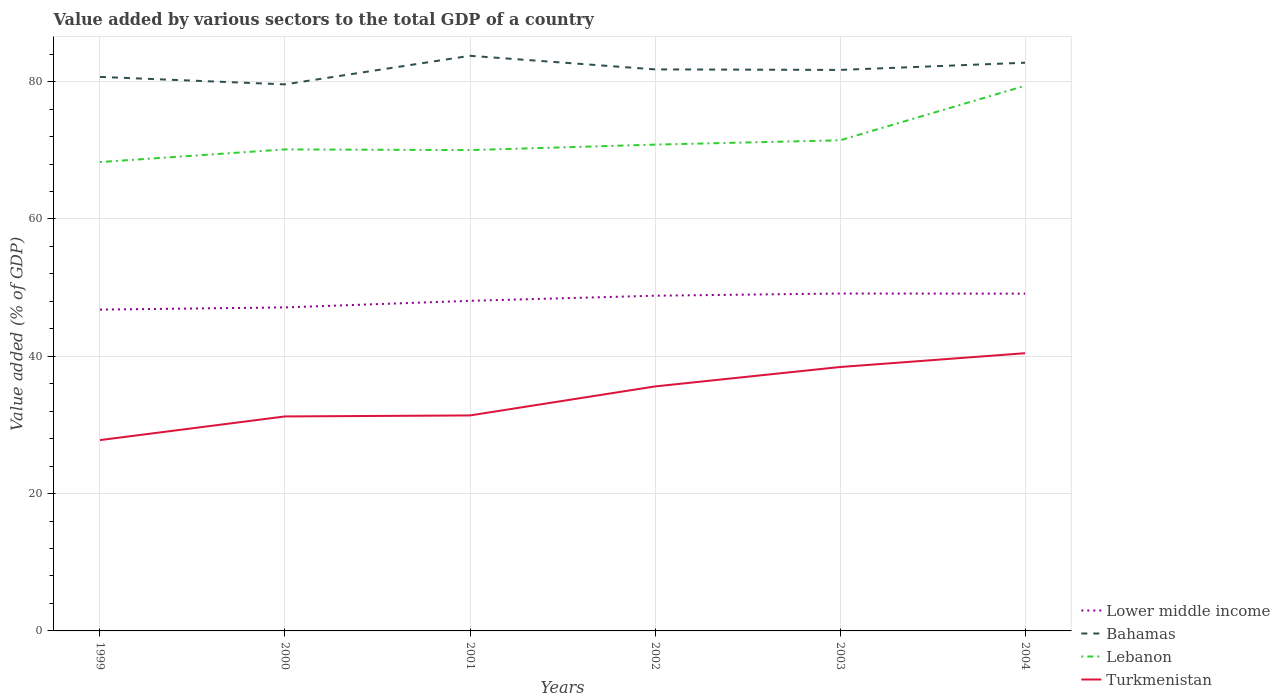How many different coloured lines are there?
Provide a succinct answer. 4. Does the line corresponding to Turkmenistan intersect with the line corresponding to Lower middle income?
Your answer should be very brief. No. Is the number of lines equal to the number of legend labels?
Give a very brief answer. Yes. Across all years, what is the maximum value added by various sectors to the total GDP in Bahamas?
Keep it short and to the point. 79.6. What is the total value added by various sectors to the total GDP in Lower middle income in the graph?
Keep it short and to the point. -2.01. What is the difference between the highest and the second highest value added by various sectors to the total GDP in Bahamas?
Ensure brevity in your answer.  4.16. Is the value added by various sectors to the total GDP in Bahamas strictly greater than the value added by various sectors to the total GDP in Lower middle income over the years?
Provide a succinct answer. No. What is the difference between two consecutive major ticks on the Y-axis?
Make the answer very short. 20. Are the values on the major ticks of Y-axis written in scientific E-notation?
Your response must be concise. No. Does the graph contain grids?
Provide a short and direct response. Yes. Where does the legend appear in the graph?
Your answer should be compact. Bottom right. How many legend labels are there?
Keep it short and to the point. 4. How are the legend labels stacked?
Your response must be concise. Vertical. What is the title of the graph?
Offer a very short reply. Value added by various sectors to the total GDP of a country. What is the label or title of the Y-axis?
Your answer should be compact. Value added (% of GDP). What is the Value added (% of GDP) of Lower middle income in 1999?
Give a very brief answer. 46.8. What is the Value added (% of GDP) in Bahamas in 1999?
Offer a very short reply. 80.69. What is the Value added (% of GDP) of Lebanon in 1999?
Provide a succinct answer. 68.29. What is the Value added (% of GDP) in Turkmenistan in 1999?
Give a very brief answer. 27.79. What is the Value added (% of GDP) in Lower middle income in 2000?
Provide a short and direct response. 47.12. What is the Value added (% of GDP) of Bahamas in 2000?
Your response must be concise. 79.6. What is the Value added (% of GDP) in Lebanon in 2000?
Offer a terse response. 70.13. What is the Value added (% of GDP) in Turkmenistan in 2000?
Provide a short and direct response. 31.24. What is the Value added (% of GDP) of Lower middle income in 2001?
Your response must be concise. 48.08. What is the Value added (% of GDP) of Bahamas in 2001?
Offer a very short reply. 83.77. What is the Value added (% of GDP) in Lebanon in 2001?
Provide a succinct answer. 70.03. What is the Value added (% of GDP) in Turkmenistan in 2001?
Make the answer very short. 31.38. What is the Value added (% of GDP) of Lower middle income in 2002?
Make the answer very short. 48.82. What is the Value added (% of GDP) of Bahamas in 2002?
Your answer should be compact. 81.79. What is the Value added (% of GDP) of Lebanon in 2002?
Offer a very short reply. 70.83. What is the Value added (% of GDP) of Turkmenistan in 2002?
Your response must be concise. 35.61. What is the Value added (% of GDP) of Lower middle income in 2003?
Offer a terse response. 49.14. What is the Value added (% of GDP) in Bahamas in 2003?
Ensure brevity in your answer.  81.71. What is the Value added (% of GDP) of Lebanon in 2003?
Your response must be concise. 71.46. What is the Value added (% of GDP) of Turkmenistan in 2003?
Ensure brevity in your answer.  38.44. What is the Value added (% of GDP) in Lower middle income in 2004?
Your response must be concise. 49.12. What is the Value added (% of GDP) in Bahamas in 2004?
Your answer should be very brief. 82.76. What is the Value added (% of GDP) of Lebanon in 2004?
Ensure brevity in your answer.  79.4. What is the Value added (% of GDP) of Turkmenistan in 2004?
Offer a very short reply. 40.45. Across all years, what is the maximum Value added (% of GDP) of Lower middle income?
Give a very brief answer. 49.14. Across all years, what is the maximum Value added (% of GDP) in Bahamas?
Your answer should be very brief. 83.77. Across all years, what is the maximum Value added (% of GDP) of Lebanon?
Make the answer very short. 79.4. Across all years, what is the maximum Value added (% of GDP) of Turkmenistan?
Your response must be concise. 40.45. Across all years, what is the minimum Value added (% of GDP) in Lower middle income?
Give a very brief answer. 46.8. Across all years, what is the minimum Value added (% of GDP) of Bahamas?
Keep it short and to the point. 79.6. Across all years, what is the minimum Value added (% of GDP) of Lebanon?
Your answer should be compact. 68.29. Across all years, what is the minimum Value added (% of GDP) in Turkmenistan?
Provide a short and direct response. 27.79. What is the total Value added (% of GDP) in Lower middle income in the graph?
Give a very brief answer. 289.08. What is the total Value added (% of GDP) in Bahamas in the graph?
Ensure brevity in your answer.  490.31. What is the total Value added (% of GDP) of Lebanon in the graph?
Keep it short and to the point. 430.13. What is the total Value added (% of GDP) in Turkmenistan in the graph?
Offer a very short reply. 204.91. What is the difference between the Value added (% of GDP) in Lower middle income in 1999 and that in 2000?
Keep it short and to the point. -0.32. What is the difference between the Value added (% of GDP) in Bahamas in 1999 and that in 2000?
Provide a succinct answer. 1.09. What is the difference between the Value added (% of GDP) of Lebanon in 1999 and that in 2000?
Provide a short and direct response. -1.84. What is the difference between the Value added (% of GDP) of Turkmenistan in 1999 and that in 2000?
Provide a short and direct response. -3.45. What is the difference between the Value added (% of GDP) of Lower middle income in 1999 and that in 2001?
Offer a terse response. -1.28. What is the difference between the Value added (% of GDP) in Bahamas in 1999 and that in 2001?
Your response must be concise. -3.07. What is the difference between the Value added (% of GDP) of Lebanon in 1999 and that in 2001?
Give a very brief answer. -1.74. What is the difference between the Value added (% of GDP) of Turkmenistan in 1999 and that in 2001?
Offer a terse response. -3.59. What is the difference between the Value added (% of GDP) of Lower middle income in 1999 and that in 2002?
Your response must be concise. -2.03. What is the difference between the Value added (% of GDP) in Bahamas in 1999 and that in 2002?
Your response must be concise. -1.1. What is the difference between the Value added (% of GDP) in Lebanon in 1999 and that in 2002?
Provide a short and direct response. -2.54. What is the difference between the Value added (% of GDP) of Turkmenistan in 1999 and that in 2002?
Provide a short and direct response. -7.82. What is the difference between the Value added (% of GDP) of Lower middle income in 1999 and that in 2003?
Keep it short and to the point. -2.34. What is the difference between the Value added (% of GDP) in Bahamas in 1999 and that in 2003?
Offer a very short reply. -1.02. What is the difference between the Value added (% of GDP) in Lebanon in 1999 and that in 2003?
Ensure brevity in your answer.  -3.17. What is the difference between the Value added (% of GDP) of Turkmenistan in 1999 and that in 2003?
Make the answer very short. -10.64. What is the difference between the Value added (% of GDP) in Lower middle income in 1999 and that in 2004?
Your response must be concise. -2.33. What is the difference between the Value added (% of GDP) of Bahamas in 1999 and that in 2004?
Make the answer very short. -2.07. What is the difference between the Value added (% of GDP) in Lebanon in 1999 and that in 2004?
Your answer should be very brief. -11.11. What is the difference between the Value added (% of GDP) in Turkmenistan in 1999 and that in 2004?
Ensure brevity in your answer.  -12.66. What is the difference between the Value added (% of GDP) in Lower middle income in 2000 and that in 2001?
Provide a short and direct response. -0.96. What is the difference between the Value added (% of GDP) of Bahamas in 2000 and that in 2001?
Make the answer very short. -4.16. What is the difference between the Value added (% of GDP) in Lebanon in 2000 and that in 2001?
Make the answer very short. 0.1. What is the difference between the Value added (% of GDP) in Turkmenistan in 2000 and that in 2001?
Provide a short and direct response. -0.14. What is the difference between the Value added (% of GDP) in Lower middle income in 2000 and that in 2002?
Provide a succinct answer. -1.71. What is the difference between the Value added (% of GDP) in Bahamas in 2000 and that in 2002?
Give a very brief answer. -2.18. What is the difference between the Value added (% of GDP) in Lebanon in 2000 and that in 2002?
Keep it short and to the point. -0.7. What is the difference between the Value added (% of GDP) of Turkmenistan in 2000 and that in 2002?
Your answer should be compact. -4.37. What is the difference between the Value added (% of GDP) in Lower middle income in 2000 and that in 2003?
Keep it short and to the point. -2.02. What is the difference between the Value added (% of GDP) in Bahamas in 2000 and that in 2003?
Make the answer very short. -2.11. What is the difference between the Value added (% of GDP) of Lebanon in 2000 and that in 2003?
Offer a terse response. -1.33. What is the difference between the Value added (% of GDP) in Turkmenistan in 2000 and that in 2003?
Provide a succinct answer. -7.2. What is the difference between the Value added (% of GDP) in Lower middle income in 2000 and that in 2004?
Offer a terse response. -2.01. What is the difference between the Value added (% of GDP) of Bahamas in 2000 and that in 2004?
Your answer should be compact. -3.15. What is the difference between the Value added (% of GDP) of Lebanon in 2000 and that in 2004?
Ensure brevity in your answer.  -9.27. What is the difference between the Value added (% of GDP) of Turkmenistan in 2000 and that in 2004?
Your answer should be compact. -9.21. What is the difference between the Value added (% of GDP) in Lower middle income in 2001 and that in 2002?
Give a very brief answer. -0.75. What is the difference between the Value added (% of GDP) of Bahamas in 2001 and that in 2002?
Keep it short and to the point. 1.98. What is the difference between the Value added (% of GDP) of Lebanon in 2001 and that in 2002?
Offer a terse response. -0.8. What is the difference between the Value added (% of GDP) of Turkmenistan in 2001 and that in 2002?
Provide a succinct answer. -4.22. What is the difference between the Value added (% of GDP) of Lower middle income in 2001 and that in 2003?
Your answer should be very brief. -1.06. What is the difference between the Value added (% of GDP) in Bahamas in 2001 and that in 2003?
Offer a terse response. 2.06. What is the difference between the Value added (% of GDP) of Lebanon in 2001 and that in 2003?
Your answer should be compact. -1.43. What is the difference between the Value added (% of GDP) of Turkmenistan in 2001 and that in 2003?
Give a very brief answer. -7.05. What is the difference between the Value added (% of GDP) of Lower middle income in 2001 and that in 2004?
Your answer should be compact. -1.05. What is the difference between the Value added (% of GDP) in Bahamas in 2001 and that in 2004?
Offer a very short reply. 1.01. What is the difference between the Value added (% of GDP) in Lebanon in 2001 and that in 2004?
Provide a short and direct response. -9.37. What is the difference between the Value added (% of GDP) in Turkmenistan in 2001 and that in 2004?
Give a very brief answer. -9.06. What is the difference between the Value added (% of GDP) in Lower middle income in 2002 and that in 2003?
Ensure brevity in your answer.  -0.32. What is the difference between the Value added (% of GDP) in Bahamas in 2002 and that in 2003?
Keep it short and to the point. 0.08. What is the difference between the Value added (% of GDP) in Lebanon in 2002 and that in 2003?
Ensure brevity in your answer.  -0.63. What is the difference between the Value added (% of GDP) of Turkmenistan in 2002 and that in 2003?
Offer a very short reply. -2.83. What is the difference between the Value added (% of GDP) of Lower middle income in 2002 and that in 2004?
Provide a short and direct response. -0.3. What is the difference between the Value added (% of GDP) of Bahamas in 2002 and that in 2004?
Make the answer very short. -0.97. What is the difference between the Value added (% of GDP) in Lebanon in 2002 and that in 2004?
Make the answer very short. -8.57. What is the difference between the Value added (% of GDP) of Turkmenistan in 2002 and that in 2004?
Keep it short and to the point. -4.84. What is the difference between the Value added (% of GDP) in Lower middle income in 2003 and that in 2004?
Provide a succinct answer. 0.02. What is the difference between the Value added (% of GDP) in Bahamas in 2003 and that in 2004?
Your response must be concise. -1.05. What is the difference between the Value added (% of GDP) of Lebanon in 2003 and that in 2004?
Offer a very short reply. -7.94. What is the difference between the Value added (% of GDP) of Turkmenistan in 2003 and that in 2004?
Offer a very short reply. -2.01. What is the difference between the Value added (% of GDP) in Lower middle income in 1999 and the Value added (% of GDP) in Bahamas in 2000?
Offer a very short reply. -32.8. What is the difference between the Value added (% of GDP) of Lower middle income in 1999 and the Value added (% of GDP) of Lebanon in 2000?
Keep it short and to the point. -23.33. What is the difference between the Value added (% of GDP) of Lower middle income in 1999 and the Value added (% of GDP) of Turkmenistan in 2000?
Your answer should be very brief. 15.56. What is the difference between the Value added (% of GDP) in Bahamas in 1999 and the Value added (% of GDP) in Lebanon in 2000?
Your response must be concise. 10.56. What is the difference between the Value added (% of GDP) in Bahamas in 1999 and the Value added (% of GDP) in Turkmenistan in 2000?
Give a very brief answer. 49.45. What is the difference between the Value added (% of GDP) in Lebanon in 1999 and the Value added (% of GDP) in Turkmenistan in 2000?
Offer a terse response. 37.05. What is the difference between the Value added (% of GDP) in Lower middle income in 1999 and the Value added (% of GDP) in Bahamas in 2001?
Your answer should be compact. -36.97. What is the difference between the Value added (% of GDP) in Lower middle income in 1999 and the Value added (% of GDP) in Lebanon in 2001?
Offer a terse response. -23.23. What is the difference between the Value added (% of GDP) in Lower middle income in 1999 and the Value added (% of GDP) in Turkmenistan in 2001?
Your answer should be compact. 15.41. What is the difference between the Value added (% of GDP) in Bahamas in 1999 and the Value added (% of GDP) in Lebanon in 2001?
Provide a short and direct response. 10.66. What is the difference between the Value added (% of GDP) in Bahamas in 1999 and the Value added (% of GDP) in Turkmenistan in 2001?
Provide a short and direct response. 49.31. What is the difference between the Value added (% of GDP) in Lebanon in 1999 and the Value added (% of GDP) in Turkmenistan in 2001?
Your answer should be compact. 36.9. What is the difference between the Value added (% of GDP) of Lower middle income in 1999 and the Value added (% of GDP) of Bahamas in 2002?
Your response must be concise. -34.99. What is the difference between the Value added (% of GDP) of Lower middle income in 1999 and the Value added (% of GDP) of Lebanon in 2002?
Provide a short and direct response. -24.03. What is the difference between the Value added (% of GDP) of Lower middle income in 1999 and the Value added (% of GDP) of Turkmenistan in 2002?
Provide a short and direct response. 11.19. What is the difference between the Value added (% of GDP) of Bahamas in 1999 and the Value added (% of GDP) of Lebanon in 2002?
Offer a very short reply. 9.86. What is the difference between the Value added (% of GDP) of Bahamas in 1999 and the Value added (% of GDP) of Turkmenistan in 2002?
Ensure brevity in your answer.  45.08. What is the difference between the Value added (% of GDP) of Lebanon in 1999 and the Value added (% of GDP) of Turkmenistan in 2002?
Your answer should be compact. 32.68. What is the difference between the Value added (% of GDP) of Lower middle income in 1999 and the Value added (% of GDP) of Bahamas in 2003?
Offer a very short reply. -34.91. What is the difference between the Value added (% of GDP) of Lower middle income in 1999 and the Value added (% of GDP) of Lebanon in 2003?
Ensure brevity in your answer.  -24.66. What is the difference between the Value added (% of GDP) of Lower middle income in 1999 and the Value added (% of GDP) of Turkmenistan in 2003?
Make the answer very short. 8.36. What is the difference between the Value added (% of GDP) of Bahamas in 1999 and the Value added (% of GDP) of Lebanon in 2003?
Provide a succinct answer. 9.23. What is the difference between the Value added (% of GDP) in Bahamas in 1999 and the Value added (% of GDP) in Turkmenistan in 2003?
Offer a very short reply. 42.25. What is the difference between the Value added (% of GDP) in Lebanon in 1999 and the Value added (% of GDP) in Turkmenistan in 2003?
Your answer should be compact. 29.85. What is the difference between the Value added (% of GDP) of Lower middle income in 1999 and the Value added (% of GDP) of Bahamas in 2004?
Your response must be concise. -35.96. What is the difference between the Value added (% of GDP) in Lower middle income in 1999 and the Value added (% of GDP) in Lebanon in 2004?
Your response must be concise. -32.6. What is the difference between the Value added (% of GDP) of Lower middle income in 1999 and the Value added (% of GDP) of Turkmenistan in 2004?
Your response must be concise. 6.35. What is the difference between the Value added (% of GDP) of Bahamas in 1999 and the Value added (% of GDP) of Lebanon in 2004?
Offer a very short reply. 1.29. What is the difference between the Value added (% of GDP) of Bahamas in 1999 and the Value added (% of GDP) of Turkmenistan in 2004?
Your response must be concise. 40.24. What is the difference between the Value added (% of GDP) of Lebanon in 1999 and the Value added (% of GDP) of Turkmenistan in 2004?
Ensure brevity in your answer.  27.84. What is the difference between the Value added (% of GDP) in Lower middle income in 2000 and the Value added (% of GDP) in Bahamas in 2001?
Keep it short and to the point. -36.65. What is the difference between the Value added (% of GDP) in Lower middle income in 2000 and the Value added (% of GDP) in Lebanon in 2001?
Your answer should be very brief. -22.91. What is the difference between the Value added (% of GDP) in Lower middle income in 2000 and the Value added (% of GDP) in Turkmenistan in 2001?
Offer a terse response. 15.73. What is the difference between the Value added (% of GDP) of Bahamas in 2000 and the Value added (% of GDP) of Lebanon in 2001?
Ensure brevity in your answer.  9.57. What is the difference between the Value added (% of GDP) of Bahamas in 2000 and the Value added (% of GDP) of Turkmenistan in 2001?
Provide a short and direct response. 48.22. What is the difference between the Value added (% of GDP) in Lebanon in 2000 and the Value added (% of GDP) in Turkmenistan in 2001?
Make the answer very short. 38.75. What is the difference between the Value added (% of GDP) of Lower middle income in 2000 and the Value added (% of GDP) of Bahamas in 2002?
Give a very brief answer. -34.67. What is the difference between the Value added (% of GDP) of Lower middle income in 2000 and the Value added (% of GDP) of Lebanon in 2002?
Provide a succinct answer. -23.71. What is the difference between the Value added (% of GDP) in Lower middle income in 2000 and the Value added (% of GDP) in Turkmenistan in 2002?
Ensure brevity in your answer.  11.51. What is the difference between the Value added (% of GDP) of Bahamas in 2000 and the Value added (% of GDP) of Lebanon in 2002?
Make the answer very short. 8.77. What is the difference between the Value added (% of GDP) of Bahamas in 2000 and the Value added (% of GDP) of Turkmenistan in 2002?
Give a very brief answer. 43.99. What is the difference between the Value added (% of GDP) in Lebanon in 2000 and the Value added (% of GDP) in Turkmenistan in 2002?
Offer a very short reply. 34.52. What is the difference between the Value added (% of GDP) in Lower middle income in 2000 and the Value added (% of GDP) in Bahamas in 2003?
Provide a succinct answer. -34.59. What is the difference between the Value added (% of GDP) of Lower middle income in 2000 and the Value added (% of GDP) of Lebanon in 2003?
Provide a succinct answer. -24.34. What is the difference between the Value added (% of GDP) of Lower middle income in 2000 and the Value added (% of GDP) of Turkmenistan in 2003?
Offer a terse response. 8.68. What is the difference between the Value added (% of GDP) of Bahamas in 2000 and the Value added (% of GDP) of Lebanon in 2003?
Your answer should be compact. 8.14. What is the difference between the Value added (% of GDP) in Bahamas in 2000 and the Value added (% of GDP) in Turkmenistan in 2003?
Provide a short and direct response. 41.17. What is the difference between the Value added (% of GDP) in Lebanon in 2000 and the Value added (% of GDP) in Turkmenistan in 2003?
Your answer should be very brief. 31.69. What is the difference between the Value added (% of GDP) of Lower middle income in 2000 and the Value added (% of GDP) of Bahamas in 2004?
Your answer should be very brief. -35.64. What is the difference between the Value added (% of GDP) of Lower middle income in 2000 and the Value added (% of GDP) of Lebanon in 2004?
Ensure brevity in your answer.  -32.28. What is the difference between the Value added (% of GDP) in Lower middle income in 2000 and the Value added (% of GDP) in Turkmenistan in 2004?
Offer a terse response. 6.67. What is the difference between the Value added (% of GDP) in Bahamas in 2000 and the Value added (% of GDP) in Lebanon in 2004?
Offer a very short reply. 0.21. What is the difference between the Value added (% of GDP) of Bahamas in 2000 and the Value added (% of GDP) of Turkmenistan in 2004?
Ensure brevity in your answer.  39.15. What is the difference between the Value added (% of GDP) of Lebanon in 2000 and the Value added (% of GDP) of Turkmenistan in 2004?
Keep it short and to the point. 29.68. What is the difference between the Value added (% of GDP) of Lower middle income in 2001 and the Value added (% of GDP) of Bahamas in 2002?
Your answer should be very brief. -33.71. What is the difference between the Value added (% of GDP) in Lower middle income in 2001 and the Value added (% of GDP) in Lebanon in 2002?
Provide a short and direct response. -22.75. What is the difference between the Value added (% of GDP) of Lower middle income in 2001 and the Value added (% of GDP) of Turkmenistan in 2002?
Your answer should be compact. 12.47. What is the difference between the Value added (% of GDP) in Bahamas in 2001 and the Value added (% of GDP) in Lebanon in 2002?
Keep it short and to the point. 12.94. What is the difference between the Value added (% of GDP) of Bahamas in 2001 and the Value added (% of GDP) of Turkmenistan in 2002?
Offer a terse response. 48.16. What is the difference between the Value added (% of GDP) in Lebanon in 2001 and the Value added (% of GDP) in Turkmenistan in 2002?
Make the answer very short. 34.42. What is the difference between the Value added (% of GDP) of Lower middle income in 2001 and the Value added (% of GDP) of Bahamas in 2003?
Your answer should be compact. -33.63. What is the difference between the Value added (% of GDP) in Lower middle income in 2001 and the Value added (% of GDP) in Lebanon in 2003?
Provide a succinct answer. -23.38. What is the difference between the Value added (% of GDP) of Lower middle income in 2001 and the Value added (% of GDP) of Turkmenistan in 2003?
Keep it short and to the point. 9.64. What is the difference between the Value added (% of GDP) in Bahamas in 2001 and the Value added (% of GDP) in Lebanon in 2003?
Ensure brevity in your answer.  12.31. What is the difference between the Value added (% of GDP) of Bahamas in 2001 and the Value added (% of GDP) of Turkmenistan in 2003?
Give a very brief answer. 45.33. What is the difference between the Value added (% of GDP) in Lebanon in 2001 and the Value added (% of GDP) in Turkmenistan in 2003?
Provide a short and direct response. 31.59. What is the difference between the Value added (% of GDP) of Lower middle income in 2001 and the Value added (% of GDP) of Bahamas in 2004?
Provide a succinct answer. -34.68. What is the difference between the Value added (% of GDP) of Lower middle income in 2001 and the Value added (% of GDP) of Lebanon in 2004?
Offer a very short reply. -31.32. What is the difference between the Value added (% of GDP) in Lower middle income in 2001 and the Value added (% of GDP) in Turkmenistan in 2004?
Your answer should be very brief. 7.63. What is the difference between the Value added (% of GDP) of Bahamas in 2001 and the Value added (% of GDP) of Lebanon in 2004?
Offer a very short reply. 4.37. What is the difference between the Value added (% of GDP) in Bahamas in 2001 and the Value added (% of GDP) in Turkmenistan in 2004?
Offer a very short reply. 43.32. What is the difference between the Value added (% of GDP) of Lebanon in 2001 and the Value added (% of GDP) of Turkmenistan in 2004?
Give a very brief answer. 29.58. What is the difference between the Value added (% of GDP) in Lower middle income in 2002 and the Value added (% of GDP) in Bahamas in 2003?
Provide a short and direct response. -32.88. What is the difference between the Value added (% of GDP) of Lower middle income in 2002 and the Value added (% of GDP) of Lebanon in 2003?
Offer a terse response. -22.63. What is the difference between the Value added (% of GDP) in Lower middle income in 2002 and the Value added (% of GDP) in Turkmenistan in 2003?
Your answer should be very brief. 10.39. What is the difference between the Value added (% of GDP) in Bahamas in 2002 and the Value added (% of GDP) in Lebanon in 2003?
Give a very brief answer. 10.33. What is the difference between the Value added (% of GDP) of Bahamas in 2002 and the Value added (% of GDP) of Turkmenistan in 2003?
Offer a very short reply. 43.35. What is the difference between the Value added (% of GDP) in Lebanon in 2002 and the Value added (% of GDP) in Turkmenistan in 2003?
Offer a terse response. 32.39. What is the difference between the Value added (% of GDP) of Lower middle income in 2002 and the Value added (% of GDP) of Bahamas in 2004?
Your response must be concise. -33.93. What is the difference between the Value added (% of GDP) of Lower middle income in 2002 and the Value added (% of GDP) of Lebanon in 2004?
Your response must be concise. -30.57. What is the difference between the Value added (% of GDP) of Lower middle income in 2002 and the Value added (% of GDP) of Turkmenistan in 2004?
Give a very brief answer. 8.38. What is the difference between the Value added (% of GDP) of Bahamas in 2002 and the Value added (% of GDP) of Lebanon in 2004?
Offer a terse response. 2.39. What is the difference between the Value added (% of GDP) in Bahamas in 2002 and the Value added (% of GDP) in Turkmenistan in 2004?
Keep it short and to the point. 41.34. What is the difference between the Value added (% of GDP) in Lebanon in 2002 and the Value added (% of GDP) in Turkmenistan in 2004?
Your response must be concise. 30.38. What is the difference between the Value added (% of GDP) of Lower middle income in 2003 and the Value added (% of GDP) of Bahamas in 2004?
Make the answer very short. -33.62. What is the difference between the Value added (% of GDP) of Lower middle income in 2003 and the Value added (% of GDP) of Lebanon in 2004?
Provide a short and direct response. -30.26. What is the difference between the Value added (% of GDP) of Lower middle income in 2003 and the Value added (% of GDP) of Turkmenistan in 2004?
Your response must be concise. 8.69. What is the difference between the Value added (% of GDP) in Bahamas in 2003 and the Value added (% of GDP) in Lebanon in 2004?
Provide a succinct answer. 2.31. What is the difference between the Value added (% of GDP) of Bahamas in 2003 and the Value added (% of GDP) of Turkmenistan in 2004?
Offer a terse response. 41.26. What is the difference between the Value added (% of GDP) in Lebanon in 2003 and the Value added (% of GDP) in Turkmenistan in 2004?
Your answer should be very brief. 31.01. What is the average Value added (% of GDP) in Lower middle income per year?
Keep it short and to the point. 48.18. What is the average Value added (% of GDP) of Bahamas per year?
Make the answer very short. 81.72. What is the average Value added (% of GDP) in Lebanon per year?
Keep it short and to the point. 71.69. What is the average Value added (% of GDP) in Turkmenistan per year?
Offer a terse response. 34.15. In the year 1999, what is the difference between the Value added (% of GDP) of Lower middle income and Value added (% of GDP) of Bahamas?
Give a very brief answer. -33.89. In the year 1999, what is the difference between the Value added (% of GDP) in Lower middle income and Value added (% of GDP) in Lebanon?
Give a very brief answer. -21.49. In the year 1999, what is the difference between the Value added (% of GDP) in Lower middle income and Value added (% of GDP) in Turkmenistan?
Offer a terse response. 19. In the year 1999, what is the difference between the Value added (% of GDP) in Bahamas and Value added (% of GDP) in Lebanon?
Offer a terse response. 12.4. In the year 1999, what is the difference between the Value added (% of GDP) of Bahamas and Value added (% of GDP) of Turkmenistan?
Provide a short and direct response. 52.9. In the year 1999, what is the difference between the Value added (% of GDP) in Lebanon and Value added (% of GDP) in Turkmenistan?
Your response must be concise. 40.5. In the year 2000, what is the difference between the Value added (% of GDP) of Lower middle income and Value added (% of GDP) of Bahamas?
Provide a succinct answer. -32.48. In the year 2000, what is the difference between the Value added (% of GDP) in Lower middle income and Value added (% of GDP) in Lebanon?
Your answer should be compact. -23.01. In the year 2000, what is the difference between the Value added (% of GDP) in Lower middle income and Value added (% of GDP) in Turkmenistan?
Provide a short and direct response. 15.88. In the year 2000, what is the difference between the Value added (% of GDP) of Bahamas and Value added (% of GDP) of Lebanon?
Ensure brevity in your answer.  9.47. In the year 2000, what is the difference between the Value added (% of GDP) of Bahamas and Value added (% of GDP) of Turkmenistan?
Give a very brief answer. 48.36. In the year 2000, what is the difference between the Value added (% of GDP) of Lebanon and Value added (% of GDP) of Turkmenistan?
Provide a succinct answer. 38.89. In the year 2001, what is the difference between the Value added (% of GDP) in Lower middle income and Value added (% of GDP) in Bahamas?
Offer a very short reply. -35.69. In the year 2001, what is the difference between the Value added (% of GDP) in Lower middle income and Value added (% of GDP) in Lebanon?
Provide a short and direct response. -21.95. In the year 2001, what is the difference between the Value added (% of GDP) in Lower middle income and Value added (% of GDP) in Turkmenistan?
Make the answer very short. 16.69. In the year 2001, what is the difference between the Value added (% of GDP) in Bahamas and Value added (% of GDP) in Lebanon?
Offer a very short reply. 13.73. In the year 2001, what is the difference between the Value added (% of GDP) in Bahamas and Value added (% of GDP) in Turkmenistan?
Make the answer very short. 52.38. In the year 2001, what is the difference between the Value added (% of GDP) in Lebanon and Value added (% of GDP) in Turkmenistan?
Your answer should be compact. 38.65. In the year 2002, what is the difference between the Value added (% of GDP) of Lower middle income and Value added (% of GDP) of Bahamas?
Ensure brevity in your answer.  -32.96. In the year 2002, what is the difference between the Value added (% of GDP) in Lower middle income and Value added (% of GDP) in Lebanon?
Give a very brief answer. -22. In the year 2002, what is the difference between the Value added (% of GDP) of Lower middle income and Value added (% of GDP) of Turkmenistan?
Give a very brief answer. 13.21. In the year 2002, what is the difference between the Value added (% of GDP) of Bahamas and Value added (% of GDP) of Lebanon?
Provide a short and direct response. 10.96. In the year 2002, what is the difference between the Value added (% of GDP) in Bahamas and Value added (% of GDP) in Turkmenistan?
Give a very brief answer. 46.18. In the year 2002, what is the difference between the Value added (% of GDP) in Lebanon and Value added (% of GDP) in Turkmenistan?
Your answer should be compact. 35.22. In the year 2003, what is the difference between the Value added (% of GDP) of Lower middle income and Value added (% of GDP) of Bahamas?
Provide a short and direct response. -32.57. In the year 2003, what is the difference between the Value added (% of GDP) of Lower middle income and Value added (% of GDP) of Lebanon?
Make the answer very short. -22.32. In the year 2003, what is the difference between the Value added (% of GDP) of Lower middle income and Value added (% of GDP) of Turkmenistan?
Keep it short and to the point. 10.7. In the year 2003, what is the difference between the Value added (% of GDP) in Bahamas and Value added (% of GDP) in Lebanon?
Your answer should be very brief. 10.25. In the year 2003, what is the difference between the Value added (% of GDP) of Bahamas and Value added (% of GDP) of Turkmenistan?
Provide a short and direct response. 43.27. In the year 2003, what is the difference between the Value added (% of GDP) of Lebanon and Value added (% of GDP) of Turkmenistan?
Make the answer very short. 33.02. In the year 2004, what is the difference between the Value added (% of GDP) of Lower middle income and Value added (% of GDP) of Bahamas?
Give a very brief answer. -33.63. In the year 2004, what is the difference between the Value added (% of GDP) of Lower middle income and Value added (% of GDP) of Lebanon?
Your answer should be compact. -30.27. In the year 2004, what is the difference between the Value added (% of GDP) in Lower middle income and Value added (% of GDP) in Turkmenistan?
Provide a short and direct response. 8.68. In the year 2004, what is the difference between the Value added (% of GDP) of Bahamas and Value added (% of GDP) of Lebanon?
Provide a short and direct response. 3.36. In the year 2004, what is the difference between the Value added (% of GDP) of Bahamas and Value added (% of GDP) of Turkmenistan?
Your answer should be very brief. 42.31. In the year 2004, what is the difference between the Value added (% of GDP) in Lebanon and Value added (% of GDP) in Turkmenistan?
Give a very brief answer. 38.95. What is the ratio of the Value added (% of GDP) of Lower middle income in 1999 to that in 2000?
Provide a short and direct response. 0.99. What is the ratio of the Value added (% of GDP) in Bahamas in 1999 to that in 2000?
Keep it short and to the point. 1.01. What is the ratio of the Value added (% of GDP) in Lebanon in 1999 to that in 2000?
Give a very brief answer. 0.97. What is the ratio of the Value added (% of GDP) in Turkmenistan in 1999 to that in 2000?
Your answer should be very brief. 0.89. What is the ratio of the Value added (% of GDP) in Lower middle income in 1999 to that in 2001?
Your response must be concise. 0.97. What is the ratio of the Value added (% of GDP) in Bahamas in 1999 to that in 2001?
Give a very brief answer. 0.96. What is the ratio of the Value added (% of GDP) in Lebanon in 1999 to that in 2001?
Give a very brief answer. 0.98. What is the ratio of the Value added (% of GDP) in Turkmenistan in 1999 to that in 2001?
Your answer should be compact. 0.89. What is the ratio of the Value added (% of GDP) of Lower middle income in 1999 to that in 2002?
Give a very brief answer. 0.96. What is the ratio of the Value added (% of GDP) in Bahamas in 1999 to that in 2002?
Ensure brevity in your answer.  0.99. What is the ratio of the Value added (% of GDP) of Lebanon in 1999 to that in 2002?
Your answer should be compact. 0.96. What is the ratio of the Value added (% of GDP) in Turkmenistan in 1999 to that in 2002?
Keep it short and to the point. 0.78. What is the ratio of the Value added (% of GDP) of Lower middle income in 1999 to that in 2003?
Your answer should be compact. 0.95. What is the ratio of the Value added (% of GDP) of Bahamas in 1999 to that in 2003?
Make the answer very short. 0.99. What is the ratio of the Value added (% of GDP) in Lebanon in 1999 to that in 2003?
Provide a succinct answer. 0.96. What is the ratio of the Value added (% of GDP) in Turkmenistan in 1999 to that in 2003?
Your answer should be compact. 0.72. What is the ratio of the Value added (% of GDP) in Lower middle income in 1999 to that in 2004?
Provide a succinct answer. 0.95. What is the ratio of the Value added (% of GDP) of Lebanon in 1999 to that in 2004?
Your answer should be compact. 0.86. What is the ratio of the Value added (% of GDP) of Turkmenistan in 1999 to that in 2004?
Keep it short and to the point. 0.69. What is the ratio of the Value added (% of GDP) of Lower middle income in 2000 to that in 2001?
Offer a very short reply. 0.98. What is the ratio of the Value added (% of GDP) in Bahamas in 2000 to that in 2001?
Offer a terse response. 0.95. What is the ratio of the Value added (% of GDP) of Lower middle income in 2000 to that in 2002?
Give a very brief answer. 0.97. What is the ratio of the Value added (% of GDP) in Bahamas in 2000 to that in 2002?
Your answer should be compact. 0.97. What is the ratio of the Value added (% of GDP) of Turkmenistan in 2000 to that in 2002?
Provide a succinct answer. 0.88. What is the ratio of the Value added (% of GDP) in Lower middle income in 2000 to that in 2003?
Your response must be concise. 0.96. What is the ratio of the Value added (% of GDP) of Bahamas in 2000 to that in 2003?
Ensure brevity in your answer.  0.97. What is the ratio of the Value added (% of GDP) in Lebanon in 2000 to that in 2003?
Ensure brevity in your answer.  0.98. What is the ratio of the Value added (% of GDP) in Turkmenistan in 2000 to that in 2003?
Your response must be concise. 0.81. What is the ratio of the Value added (% of GDP) of Lower middle income in 2000 to that in 2004?
Ensure brevity in your answer.  0.96. What is the ratio of the Value added (% of GDP) in Bahamas in 2000 to that in 2004?
Make the answer very short. 0.96. What is the ratio of the Value added (% of GDP) in Lebanon in 2000 to that in 2004?
Give a very brief answer. 0.88. What is the ratio of the Value added (% of GDP) in Turkmenistan in 2000 to that in 2004?
Provide a short and direct response. 0.77. What is the ratio of the Value added (% of GDP) in Lower middle income in 2001 to that in 2002?
Make the answer very short. 0.98. What is the ratio of the Value added (% of GDP) in Bahamas in 2001 to that in 2002?
Provide a succinct answer. 1.02. What is the ratio of the Value added (% of GDP) of Lebanon in 2001 to that in 2002?
Your response must be concise. 0.99. What is the ratio of the Value added (% of GDP) of Turkmenistan in 2001 to that in 2002?
Keep it short and to the point. 0.88. What is the ratio of the Value added (% of GDP) of Lower middle income in 2001 to that in 2003?
Make the answer very short. 0.98. What is the ratio of the Value added (% of GDP) of Bahamas in 2001 to that in 2003?
Offer a very short reply. 1.03. What is the ratio of the Value added (% of GDP) of Lebanon in 2001 to that in 2003?
Provide a succinct answer. 0.98. What is the ratio of the Value added (% of GDP) in Turkmenistan in 2001 to that in 2003?
Ensure brevity in your answer.  0.82. What is the ratio of the Value added (% of GDP) of Lower middle income in 2001 to that in 2004?
Provide a short and direct response. 0.98. What is the ratio of the Value added (% of GDP) of Bahamas in 2001 to that in 2004?
Provide a succinct answer. 1.01. What is the ratio of the Value added (% of GDP) in Lebanon in 2001 to that in 2004?
Ensure brevity in your answer.  0.88. What is the ratio of the Value added (% of GDP) in Turkmenistan in 2001 to that in 2004?
Keep it short and to the point. 0.78. What is the ratio of the Value added (% of GDP) in Lower middle income in 2002 to that in 2003?
Your answer should be very brief. 0.99. What is the ratio of the Value added (% of GDP) of Turkmenistan in 2002 to that in 2003?
Provide a short and direct response. 0.93. What is the ratio of the Value added (% of GDP) of Bahamas in 2002 to that in 2004?
Provide a short and direct response. 0.99. What is the ratio of the Value added (% of GDP) in Lebanon in 2002 to that in 2004?
Your answer should be very brief. 0.89. What is the ratio of the Value added (% of GDP) of Turkmenistan in 2002 to that in 2004?
Your response must be concise. 0.88. What is the ratio of the Value added (% of GDP) of Bahamas in 2003 to that in 2004?
Offer a terse response. 0.99. What is the ratio of the Value added (% of GDP) of Turkmenistan in 2003 to that in 2004?
Offer a terse response. 0.95. What is the difference between the highest and the second highest Value added (% of GDP) in Lower middle income?
Provide a succinct answer. 0.02. What is the difference between the highest and the second highest Value added (% of GDP) in Bahamas?
Give a very brief answer. 1.01. What is the difference between the highest and the second highest Value added (% of GDP) of Lebanon?
Provide a short and direct response. 7.94. What is the difference between the highest and the second highest Value added (% of GDP) in Turkmenistan?
Your answer should be compact. 2.01. What is the difference between the highest and the lowest Value added (% of GDP) in Lower middle income?
Make the answer very short. 2.34. What is the difference between the highest and the lowest Value added (% of GDP) in Bahamas?
Provide a short and direct response. 4.16. What is the difference between the highest and the lowest Value added (% of GDP) of Lebanon?
Your answer should be compact. 11.11. What is the difference between the highest and the lowest Value added (% of GDP) in Turkmenistan?
Your response must be concise. 12.66. 